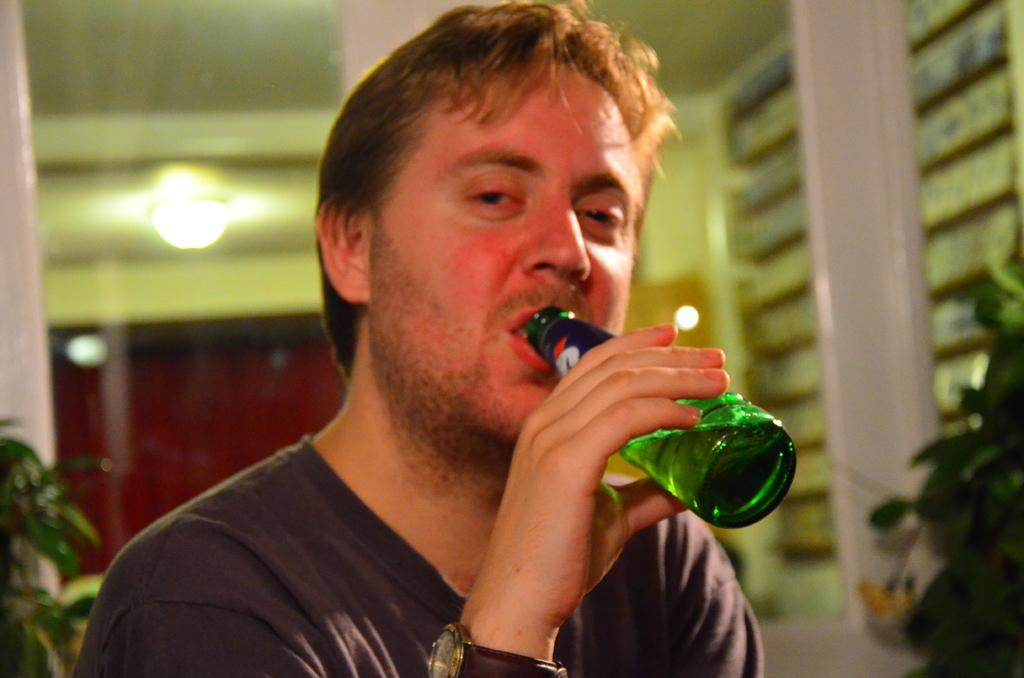What is the person in the image holding? The person is holding a green color bottle in the image. Can you describe the light visible in the image? There is a light visible in the image. What architectural features can be seen in the image? There are windows and a building visible in the image. What type of natural environment is present in the image? There are trees visible in the image. What type of throne can be seen in the image? There is no throne present in the image. How does the umbrella affect the acoustics in the image? There is no umbrella present in the image, so it cannot affect the acoustics. 